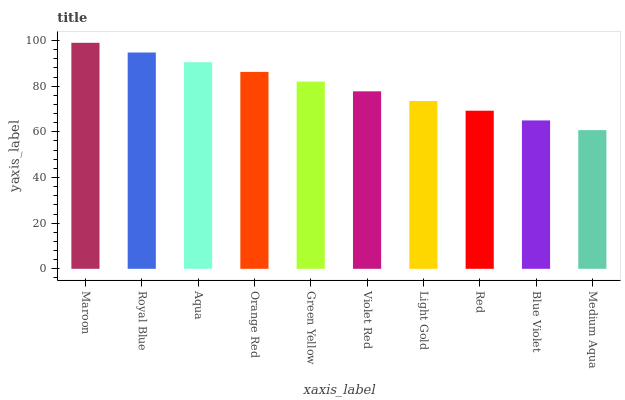Is Medium Aqua the minimum?
Answer yes or no. Yes. Is Maroon the maximum?
Answer yes or no. Yes. Is Royal Blue the minimum?
Answer yes or no. No. Is Royal Blue the maximum?
Answer yes or no. No. Is Maroon greater than Royal Blue?
Answer yes or no. Yes. Is Royal Blue less than Maroon?
Answer yes or no. Yes. Is Royal Blue greater than Maroon?
Answer yes or no. No. Is Maroon less than Royal Blue?
Answer yes or no. No. Is Green Yellow the high median?
Answer yes or no. Yes. Is Violet Red the low median?
Answer yes or no. Yes. Is Orange Red the high median?
Answer yes or no. No. Is Blue Violet the low median?
Answer yes or no. No. 